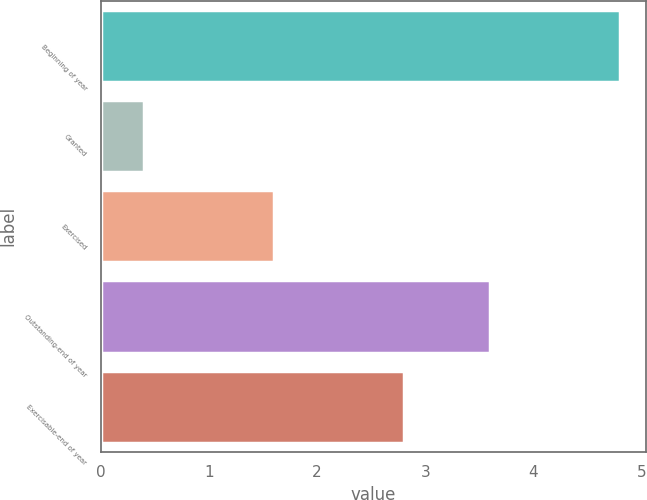<chart> <loc_0><loc_0><loc_500><loc_500><bar_chart><fcel>Beginning of year<fcel>Granted<fcel>Exercised<fcel>Outstanding-end of year<fcel>Exercisable-end of year<nl><fcel>4.8<fcel>0.4<fcel>1.6<fcel>3.6<fcel>2.8<nl></chart> 